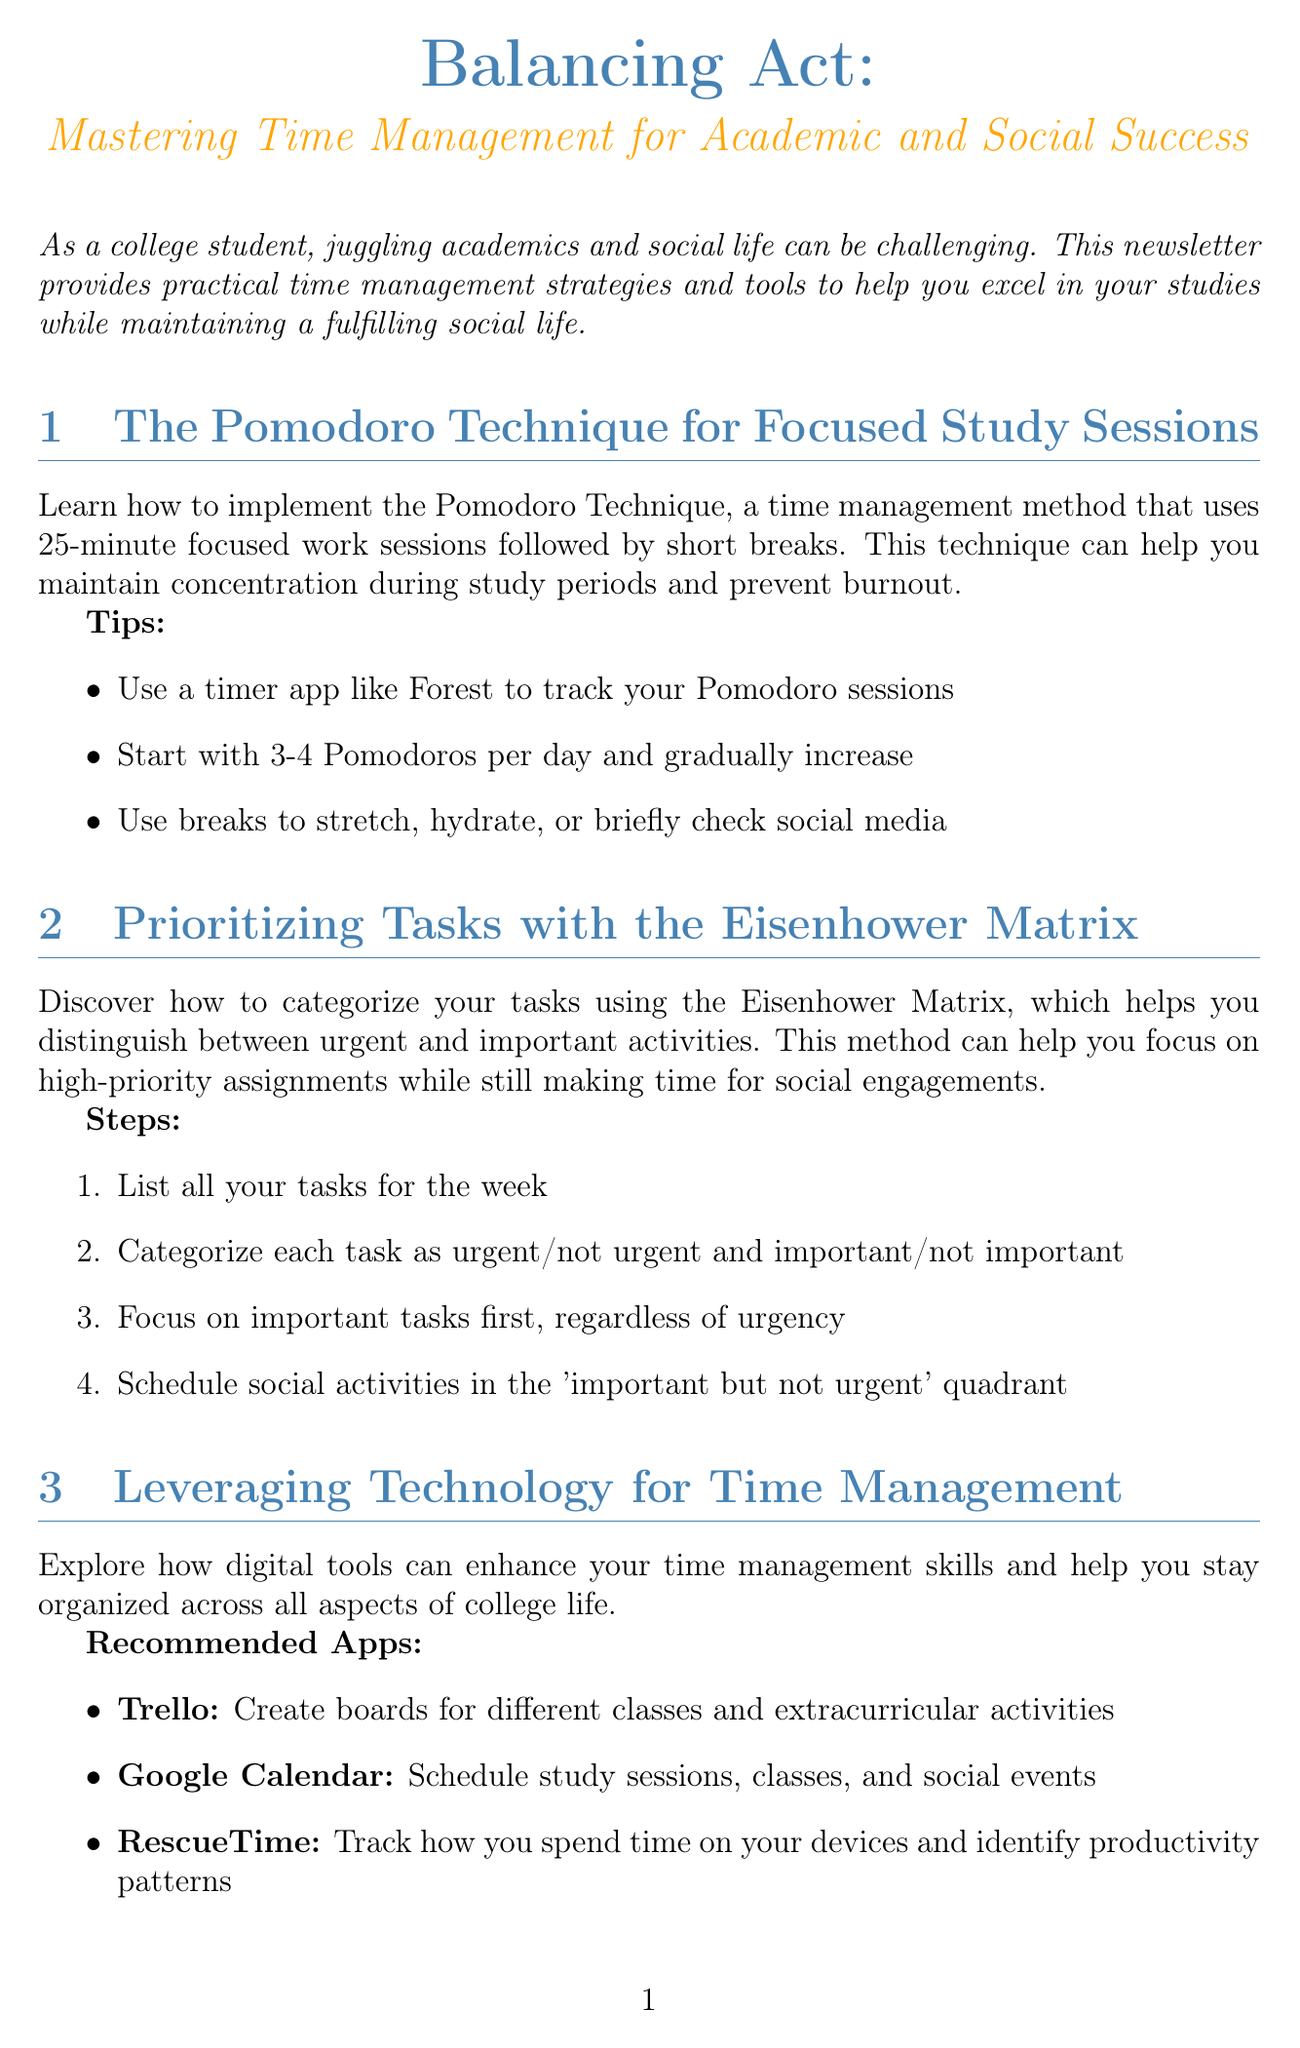What is the title of the newsletter? The title of the newsletter is provided at the beginning of the document.
Answer: Balancing Act: Mastering Time Management for Academic and Social Success How many minutes are used in a Pomodoro session? The Pomodoro Technique specifies the duration of focused work in the document.
Answer: 25 minutes What should you do during breaks according to the Pomodoro technique? The document outlines what breaks can be used for during the Pomodoro Technique.
Answer: Stretch, hydrate, or briefly check social media What is the first step in the Eisenhower Matrix? The document describes a series of steps for using the Eisenhower Matrix.
Answer: List all your tasks for the week Which app is recommended for scheduling events? The newsletter provides a list of recommended apps for time management.
Answer: Google Calendar What is one key takeaway from Sarah Chen's daily life? The document summarizes important lessons learned from Sarah Chen's experience.
Answer: Prepare for the next day the night before How many weekly planner template options are mentioned? The document outlines the number of weekly planner template options available.
Answer: Three What is a feature of the Balanced Lifestyle Planner? The document specifies particular features of different planners.
Answer: Meal planning section 